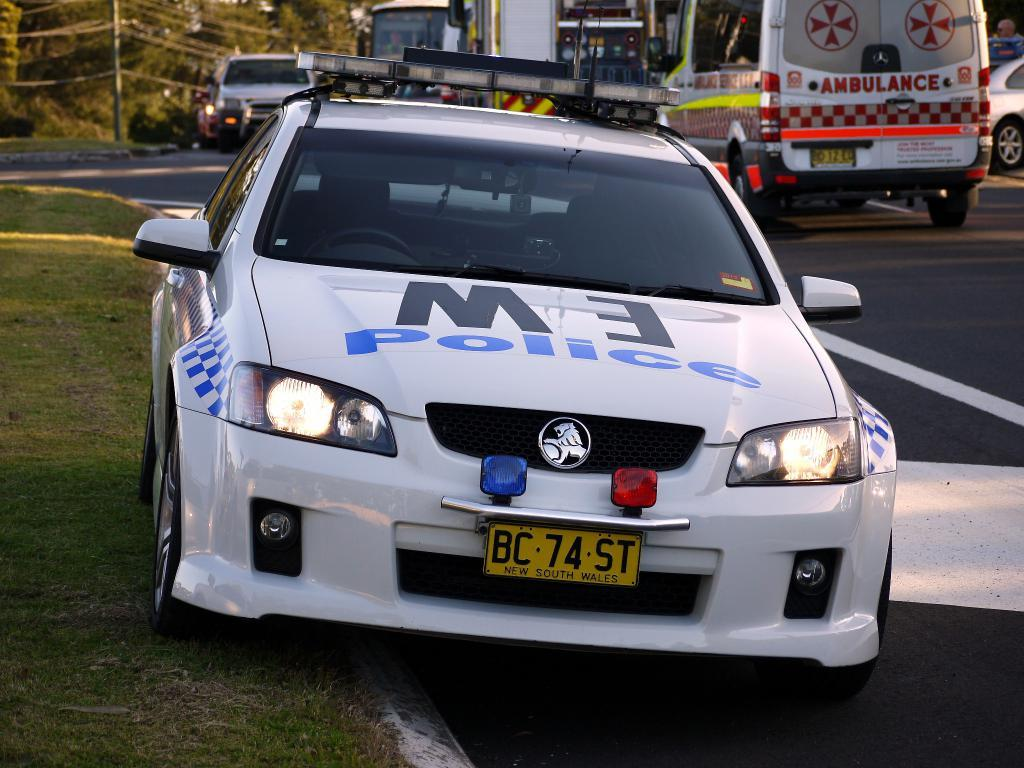What can be seen on the road in the image? There are vehicles on the road in the image. What type of vegetation is at the bottom of the image? There is grass at the bottom of the image. What is visible in the background of the image? There are trees in the background of the image. What object can be seen standing upright in the image? There is a pole visible in the image. What type of zephyr is blowing through the trees in the image? There is no mention of a zephyr or any wind in the image; it only shows vehicles on the road, grass at the bottom, trees in the background, and a pole. What is the plot of the story being told in the image? The image is not a story and does not have a plot; it is a static representation of a scene with vehicles, grass, trees, and a pole. 